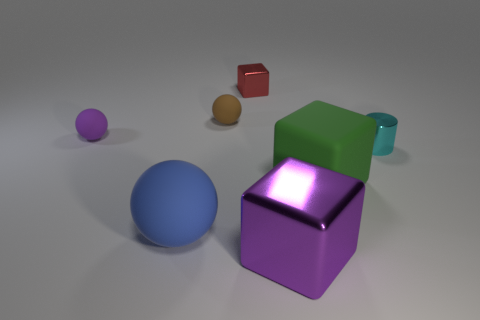Add 3 red metallic cubes. How many objects exist? 10 Subtract all cylinders. How many objects are left? 6 Add 4 tiny yellow rubber blocks. How many tiny yellow rubber blocks exist? 4 Subtract 0 cyan balls. How many objects are left? 7 Subtract all cyan shiny objects. Subtract all brown matte spheres. How many objects are left? 5 Add 4 metallic things. How many metallic things are left? 7 